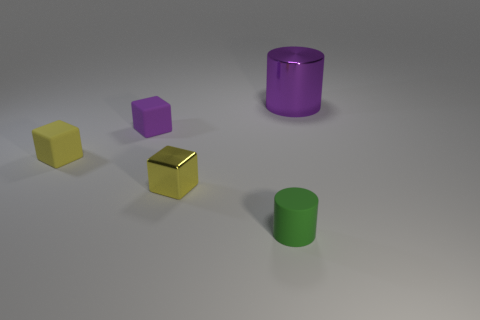Add 3 large purple metallic objects. How many objects exist? 8 Subtract all cylinders. How many objects are left? 3 Subtract all purple cubes. How many cubes are left? 2 Subtract all tiny purple blocks. How many blocks are left? 2 Subtract all gray cylinders. How many yellow blocks are left? 2 Subtract all tiny yellow matte objects. Subtract all matte blocks. How many objects are left? 2 Add 4 purple shiny objects. How many purple shiny objects are left? 5 Add 1 green cylinders. How many green cylinders exist? 2 Subtract 0 brown spheres. How many objects are left? 5 Subtract 2 cylinders. How many cylinders are left? 0 